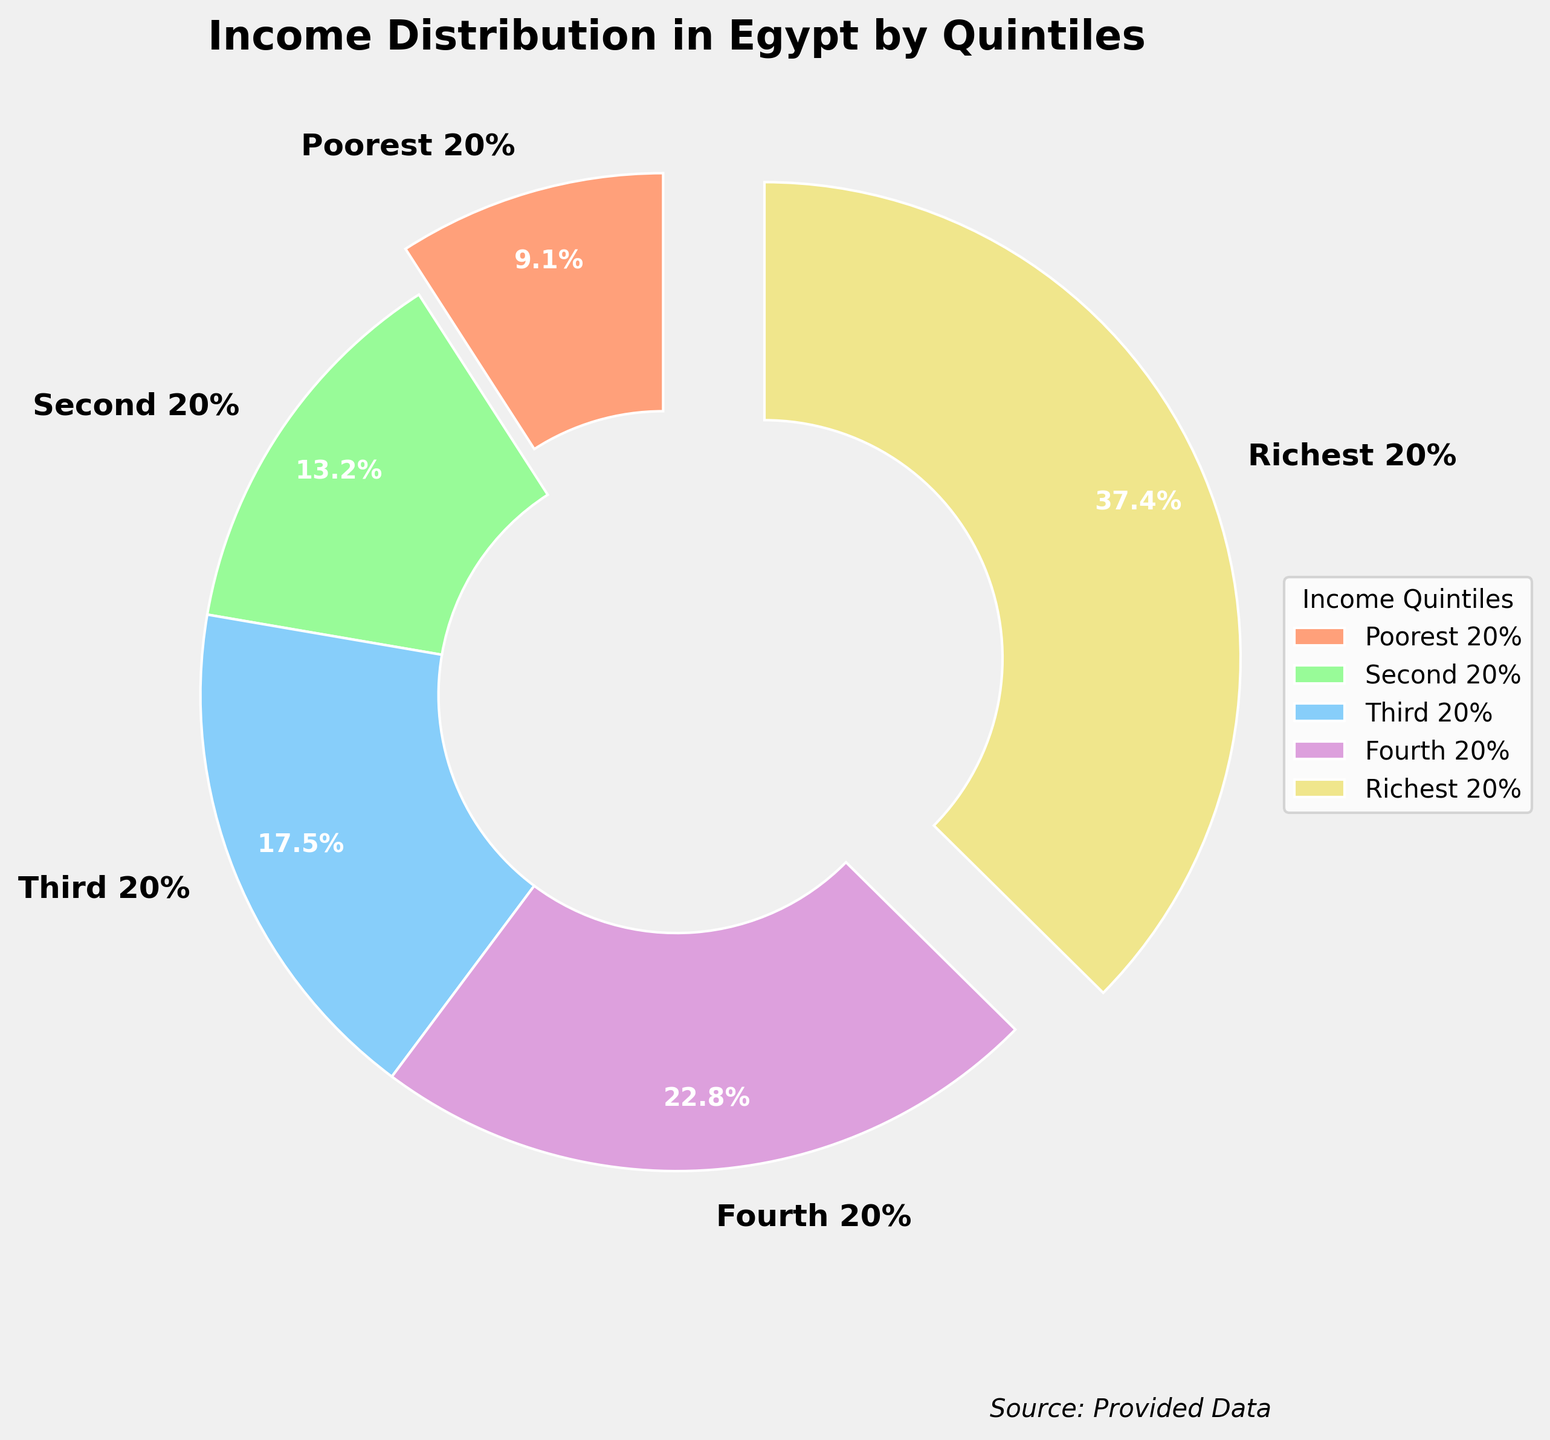What's the share of income held by the richest 20%? The pie chart shows different wealth quintiles along with their income share percentages. The richest 20% of the population holds a share of 37.4% as highlighted in the figure.
Answer: 37.4% Which quintile holds the smallest share of income? The shares of income are visually represented for each quintile. By comparing the segments, the "Poorest 20%" holds the smallest share, which is 9.1%.
Answer: Poorest 20% How much larger is the income share of the richest 20% compared to the poorest 20%? We subtract the share of the poorest 20% (9.1%) from that of the richest 20% (37.4%): 37.4% - 9.1% = 28.3%.
Answer: 28.3% What is the combined share of income held by the top 40% (Fourth 20% and Richest 20%)? Adding the shares of the Fourth 20% (22.8%) and the Richest 20% (37.4%) gives: 22.8% + 37.4% = 60.2%.
Answer: 60.2% Which color segment represents the second 20% quintile? The color coding in the figure shows that the Second 20% is represented by a light green segment.
Answer: Light green What is the sum of the shares of income held by the Poorest 20% and Third 20%? Adding the income shares of the Poorest 20% (9.1%) and the Third 20% (17.5%) gives: 9.1% + 17.5% = 26.6%.
Answer: 26.6% How much more income does the Fourth 20% hold compared to the Second 20%? Subtract the share of the Second 20% (13.2%) from the share of the Fourth 20% (22.8%): 22.8% - 13.2% = 9.6%.
Answer: 9.6% Which quintile's income share is closest to 20%? Among all the quintiles, the Third 20% has a share of 17.5%, which is closest to 20%.
Answer: Third 20% What is the average share of income for the Second 20%, Third 20%, and Fourth 20% combined? To find the average share of these three quintiles, sum their shares and divide by 3: (13.2% + 17.5% + 22.8%) / 3 = 53.5% / 3 ≈ 17.83%.
Answer: 17.83% Is the share of income held by the Fourth 20% greater than the combined share of the Poorest 20% and Second 20%? Combine the shares of the Poorest 20% (9.1%) and Second 20% (13.2%), which gives 9.1% + 13.2% = 22.3%. Since 22.8% (Fourth 20%) is greater than 22.3%, the answer is yes.
Answer: Yes 